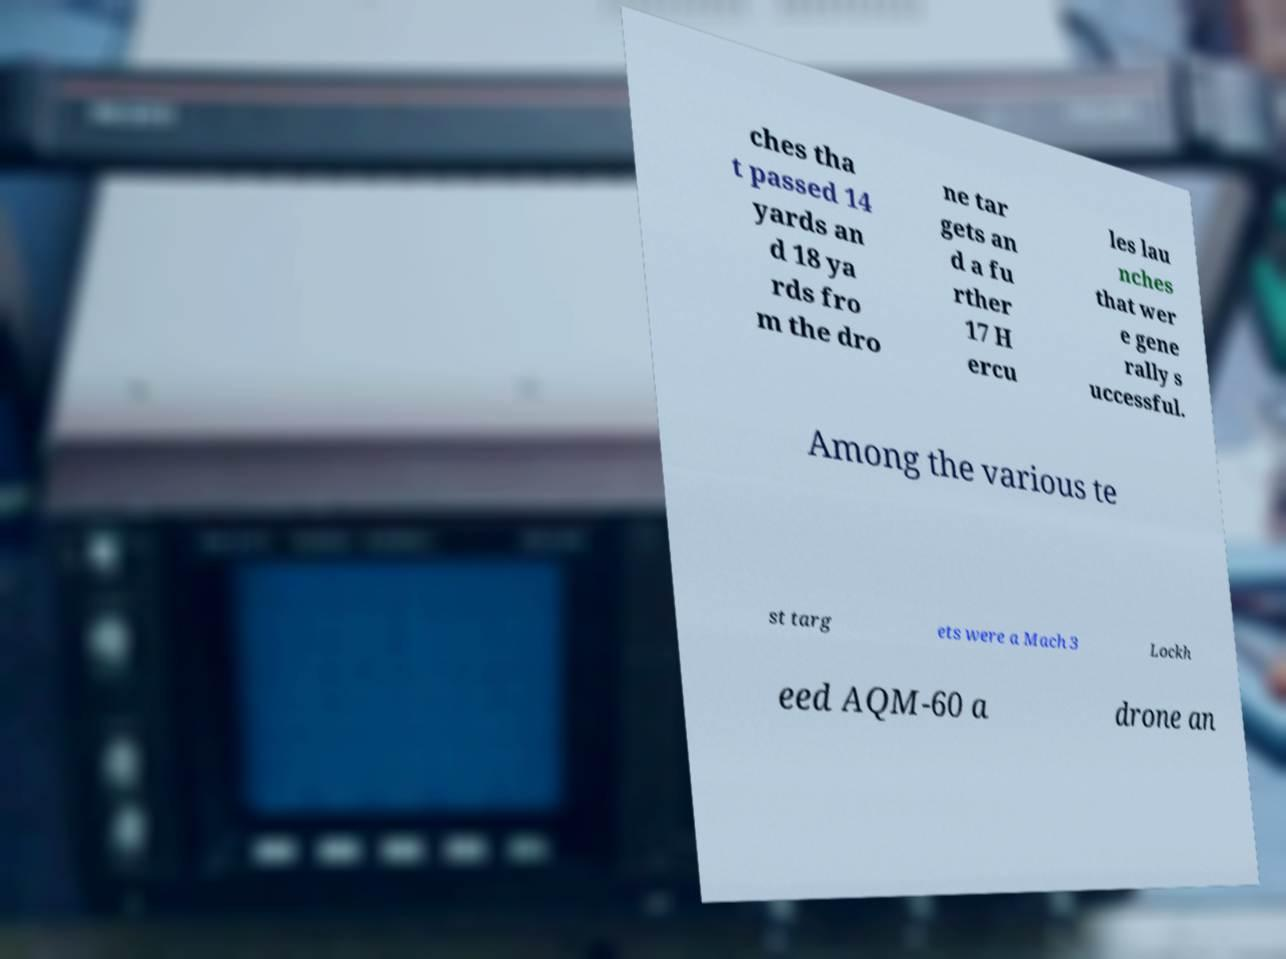Could you assist in decoding the text presented in this image and type it out clearly? ches tha t passed 14 yards an d 18 ya rds fro m the dro ne tar gets an d a fu rther 17 H ercu les lau nches that wer e gene rally s uccessful. Among the various te st targ ets were a Mach 3 Lockh eed AQM-60 a drone an 